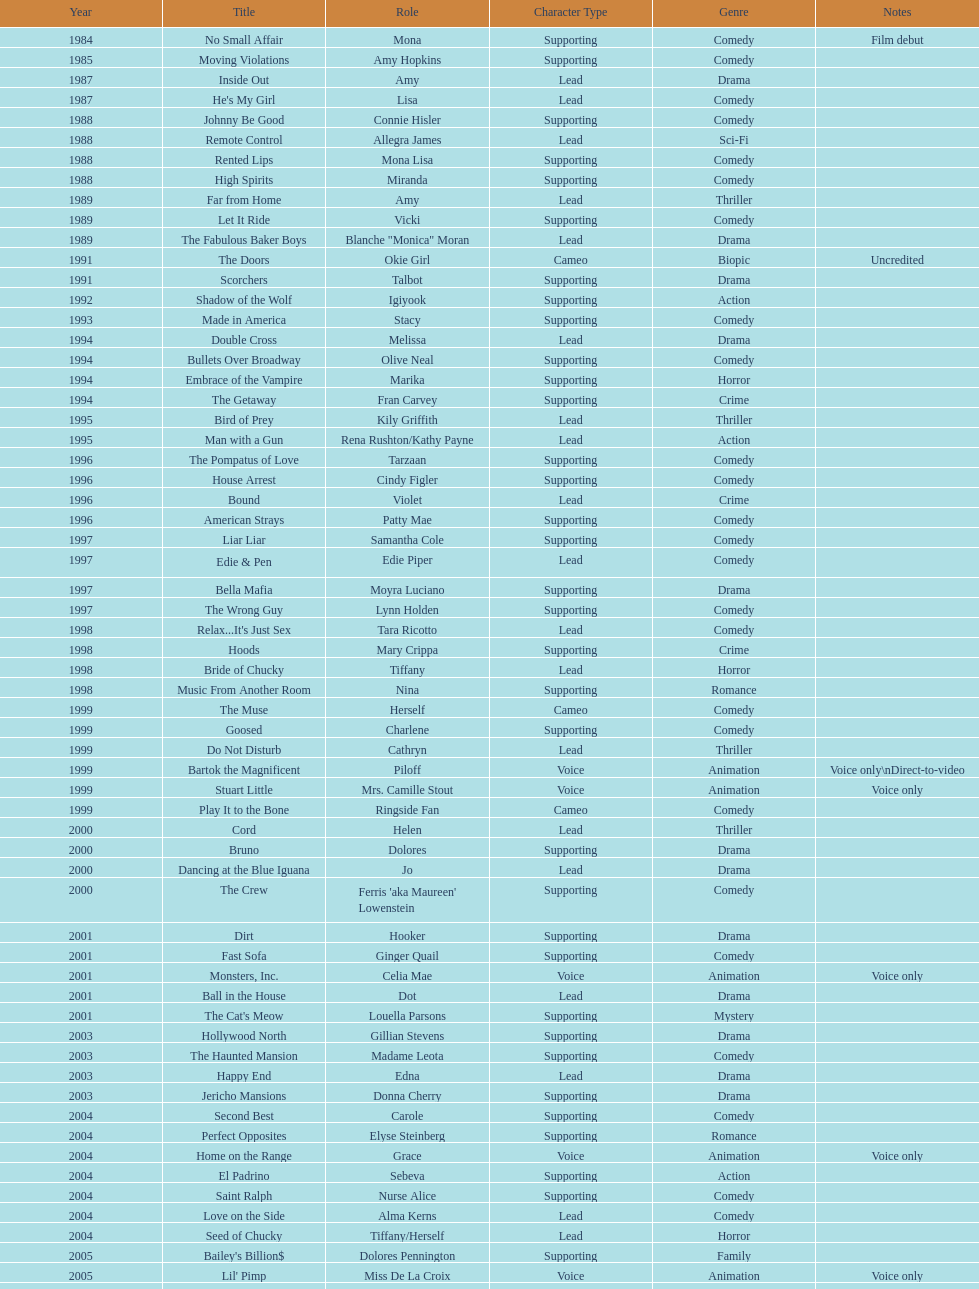Which movie was also a film debut? No Small Affair. 